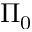<formula> <loc_0><loc_0><loc_500><loc_500>\Pi _ { 0 }</formula> 